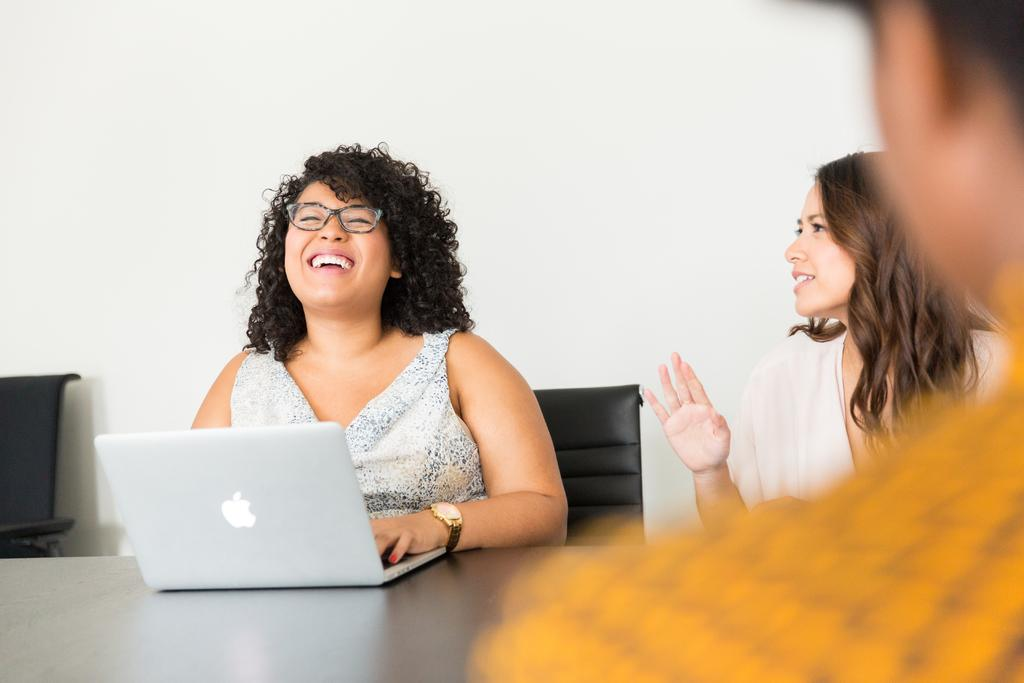What are the people in the image doing? The people in the image are sitting on chairs. How do the people appear to be feeling in the image? The people have smiles on their faces, indicating they are happy or enjoying themselves. What is located in front of the chairs? There is a table in front of the chairs. What electronic device can be seen on the table? There is a laptop on the table. Can you tell me how many waves are visible in the image? There are no waves present in the image. What type of calculator is being used by the people in the image? There is no calculator visible in the image; only a laptop is present on the table. 